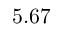<formula> <loc_0><loc_0><loc_500><loc_500>5 . 6 7</formula> 